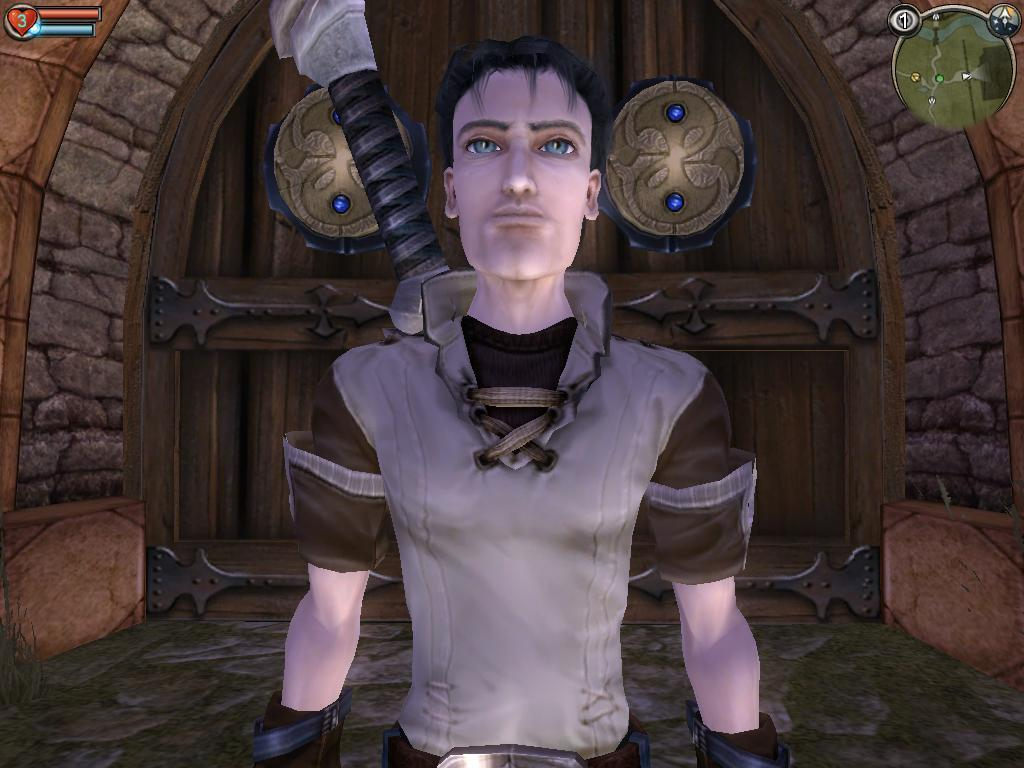What type of image is depicted in the picture? There is an animated picture of a human being in the image. What can be seen in the background of the image? There is a door and a wall in the background of the image. What type of coach is present in the image? There is no coach present in the image; it features an animated picture of a human being and a door and wall in the background. 